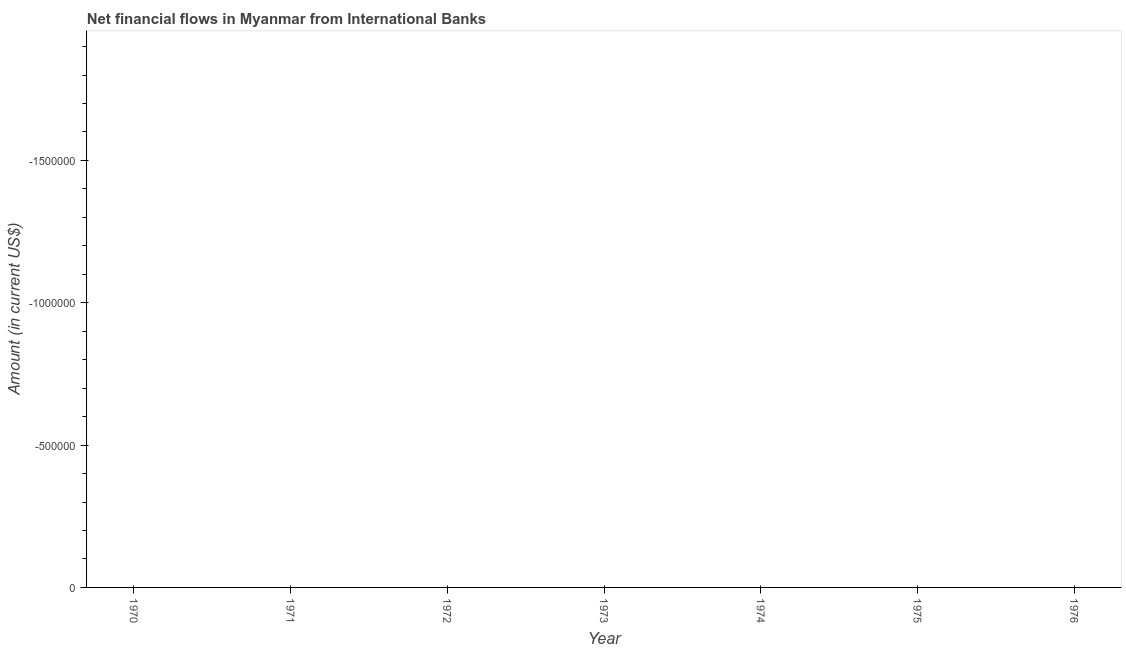What is the net financial flows from ibrd in 1974?
Provide a short and direct response. 0. Across all years, what is the minimum net financial flows from ibrd?
Offer a terse response. 0. In how many years, is the net financial flows from ibrd greater than the average net financial flows from ibrd taken over all years?
Your answer should be very brief. 0. Does the net financial flows from ibrd monotonically increase over the years?
Your response must be concise. No. How many years are there in the graph?
Ensure brevity in your answer.  7. What is the difference between two consecutive major ticks on the Y-axis?
Your answer should be compact. 5.00e+05. Are the values on the major ticks of Y-axis written in scientific E-notation?
Your answer should be very brief. No. What is the title of the graph?
Offer a very short reply. Net financial flows in Myanmar from International Banks. What is the label or title of the Y-axis?
Provide a succinct answer. Amount (in current US$). What is the Amount (in current US$) in 1970?
Offer a terse response. 0. What is the Amount (in current US$) in 1971?
Give a very brief answer. 0. What is the Amount (in current US$) in 1974?
Give a very brief answer. 0. What is the Amount (in current US$) in 1975?
Provide a succinct answer. 0. 